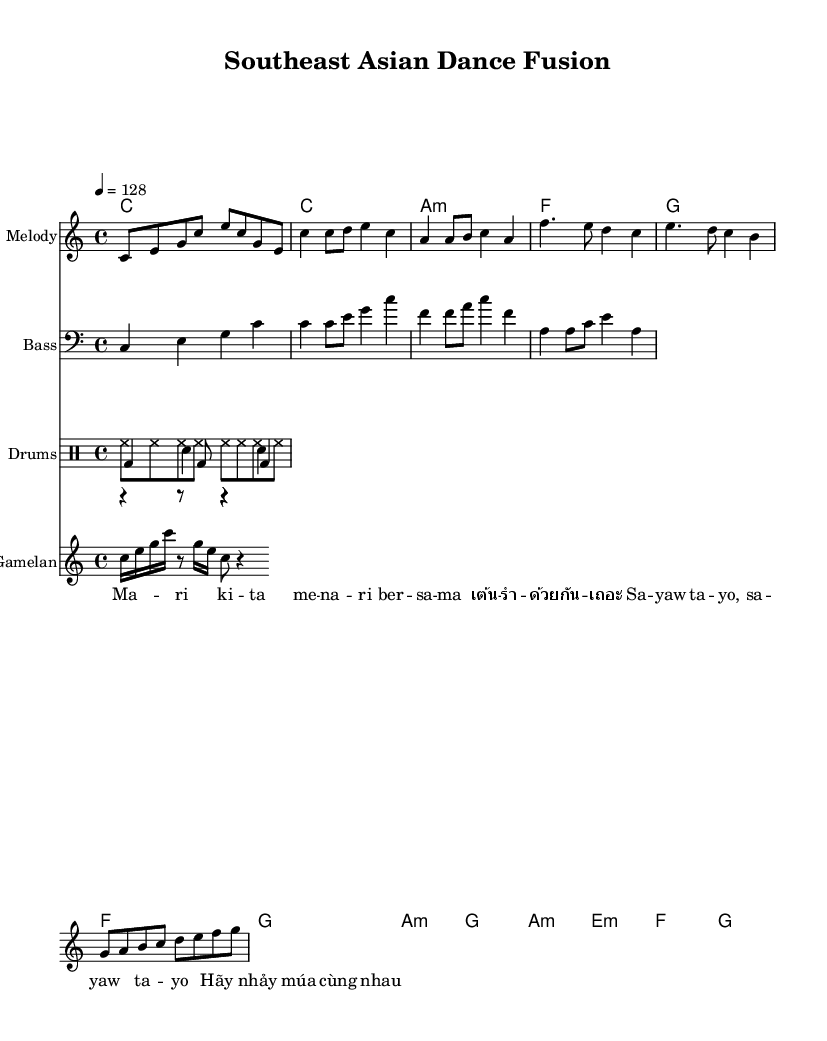What is the key signature of this music? The key signature is C major, which has no sharps or flats.
Answer: C major What is the time signature of this piece? The time signature is indicated as 4/4, meaning there are four beats in a measure.
Answer: 4/4 What is the tempo marking for the piece? The tempo marking is 128 beats per minute, as specified by the notation "4 = 128.”
Answer: 128 How many measures are there in the verse section? The verse section consists of two measures: the first measure contains two quarter notes and the second measure has four eighth notes.
Answer: 2 Which Southeast Asian languages are represented in the lyrics? The lyrics include Bahasa Indonesia, Thai, and Vietnamese.
Answer: Bahasa Indonesia, Thai, Vietnamese What type of drums are used in this piece? The percussion section includes bass drum, snare drum, and hi-hat, reflecting a standard drum kit setup suitable for dance tracks.
Answer: Bass drum, snare drum, hi-hat How does the melody section begin? The melody section begins with an ascending pattern starting from the note C, establishing a bright and lively introduction.
Answer: C E G C E C G E 